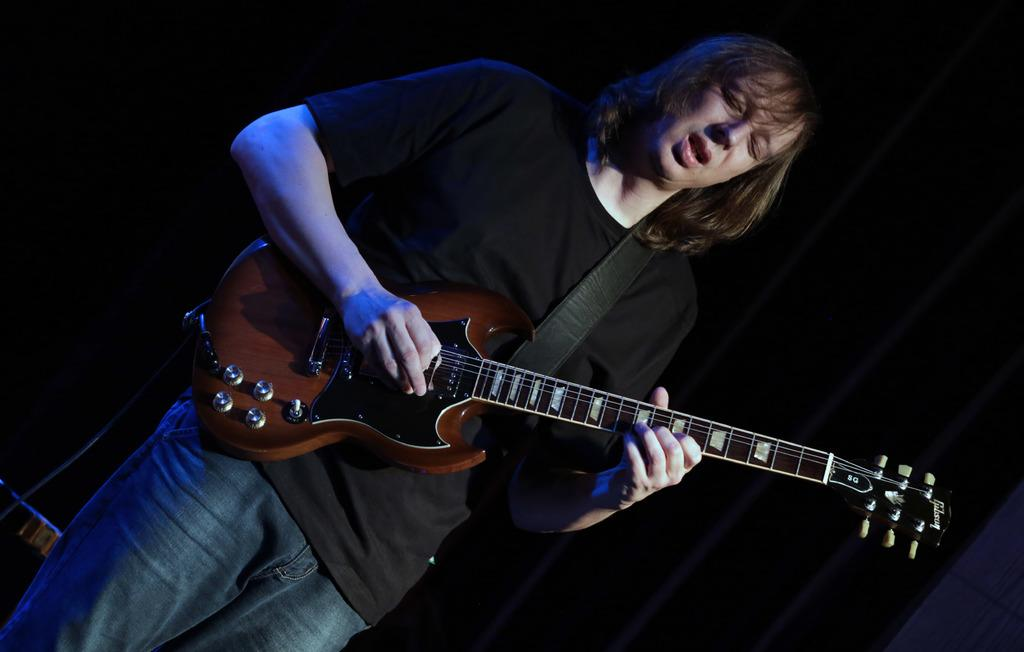What is the person in the image doing? The person is playing a guitar. Can you describe the guitar in the image? The guitar is brown in color. How is the person holding the guitar? The person is holding the guitar around their shoulders. What might the person be doing while playing the guitar? The person's mouth is open, suggesting they are singing. What is the person's eye condition in the image? The person has their eyes closed. What type of clothing is the person wearing? The person is wearing blue jeans. Where is the table located in the image? There is no table present in the image. What type of spade is the person using to dig in the image? There is no spade or digging activity present in the image. 